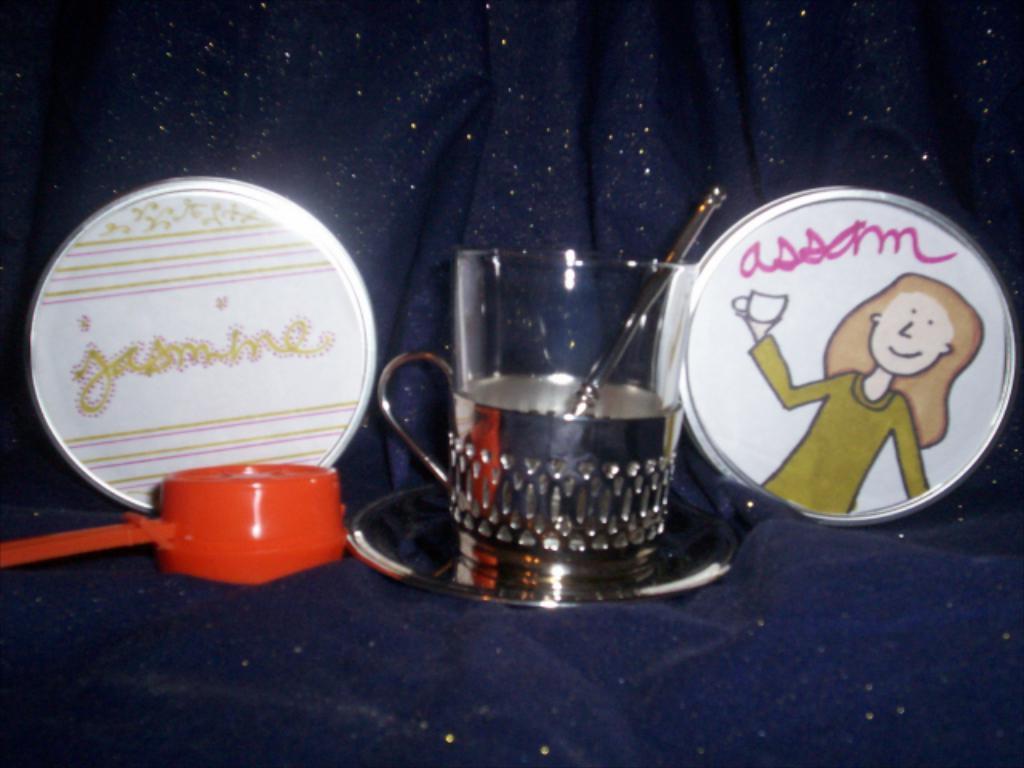Could you give a brief overview of what you see in this image? At the bottom of the image there is a couch. In the middle of the image there is a saucer, a cup and a few things on the couch. 